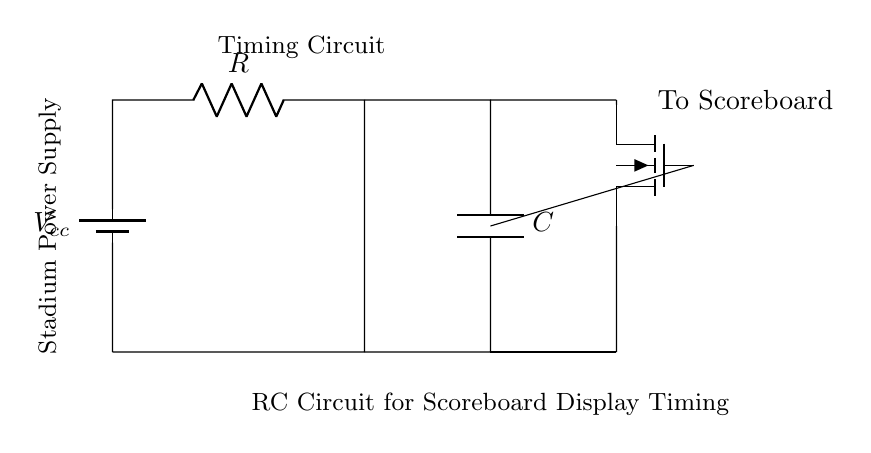What type of circuit is shown in the diagram? This circuit is an RC circuit, which includes a resistor and a capacitor, typically used for timing applications. The presence of these components for display timing suggests it's designed to control the duration of a signal based on the charge and discharge time of the capacitor.
Answer: RC circuit What is the function of the capacitor in this circuit? The capacitor in this RC circuit is used to store charge and create a timing delay for the scoreboard display. As it charges and discharges, it influences the timing of the output signal, impacting how long the scoreboard is displayed.
Answer: Timing delay What is the role of the resistor in the RC circuit? The resistor in the circuit is crucial in determining the charge and discharge time of the capacitor. The resistance value directly affects the time constant of the circuit, which is the product of resistance and capacitance, thus controlling how quickly the capacitor charges and discharges.
Answer: Control timing What does the NFET represent in this circuit? The NFET, or n-channel field-effect transistor, acts as a switch to control the flow of current to the scoreboard. When the gate receives a voltage from the capacitor, it turns on, allowing current to flow to the scoreboard and enabling the display.
Answer: Switch What is the significance of the voltage source in the circuit? The voltage source, labeled as Vcc, provides the necessary electrical power for the circuit to operate. It ensures that both the charging of the capacitor and the operation of the NFET can occur, ultimately powering the scoreboard display.
Answer: Power source What is the time constant of this RC circuit if R is 10k ohms and C is 100 microfarads? The time constant (tau) of an RC circuit is calculated using the formula tau = R * C. Here, R = 10,000 ohms and C = 0.0001 farads. Therefore, tau = 10,000 * 0.0001 = 1 second, indicating the time it takes for the voltage across the capacitor to charge to about 63.2% of the supply voltage.
Answer: 1 second 